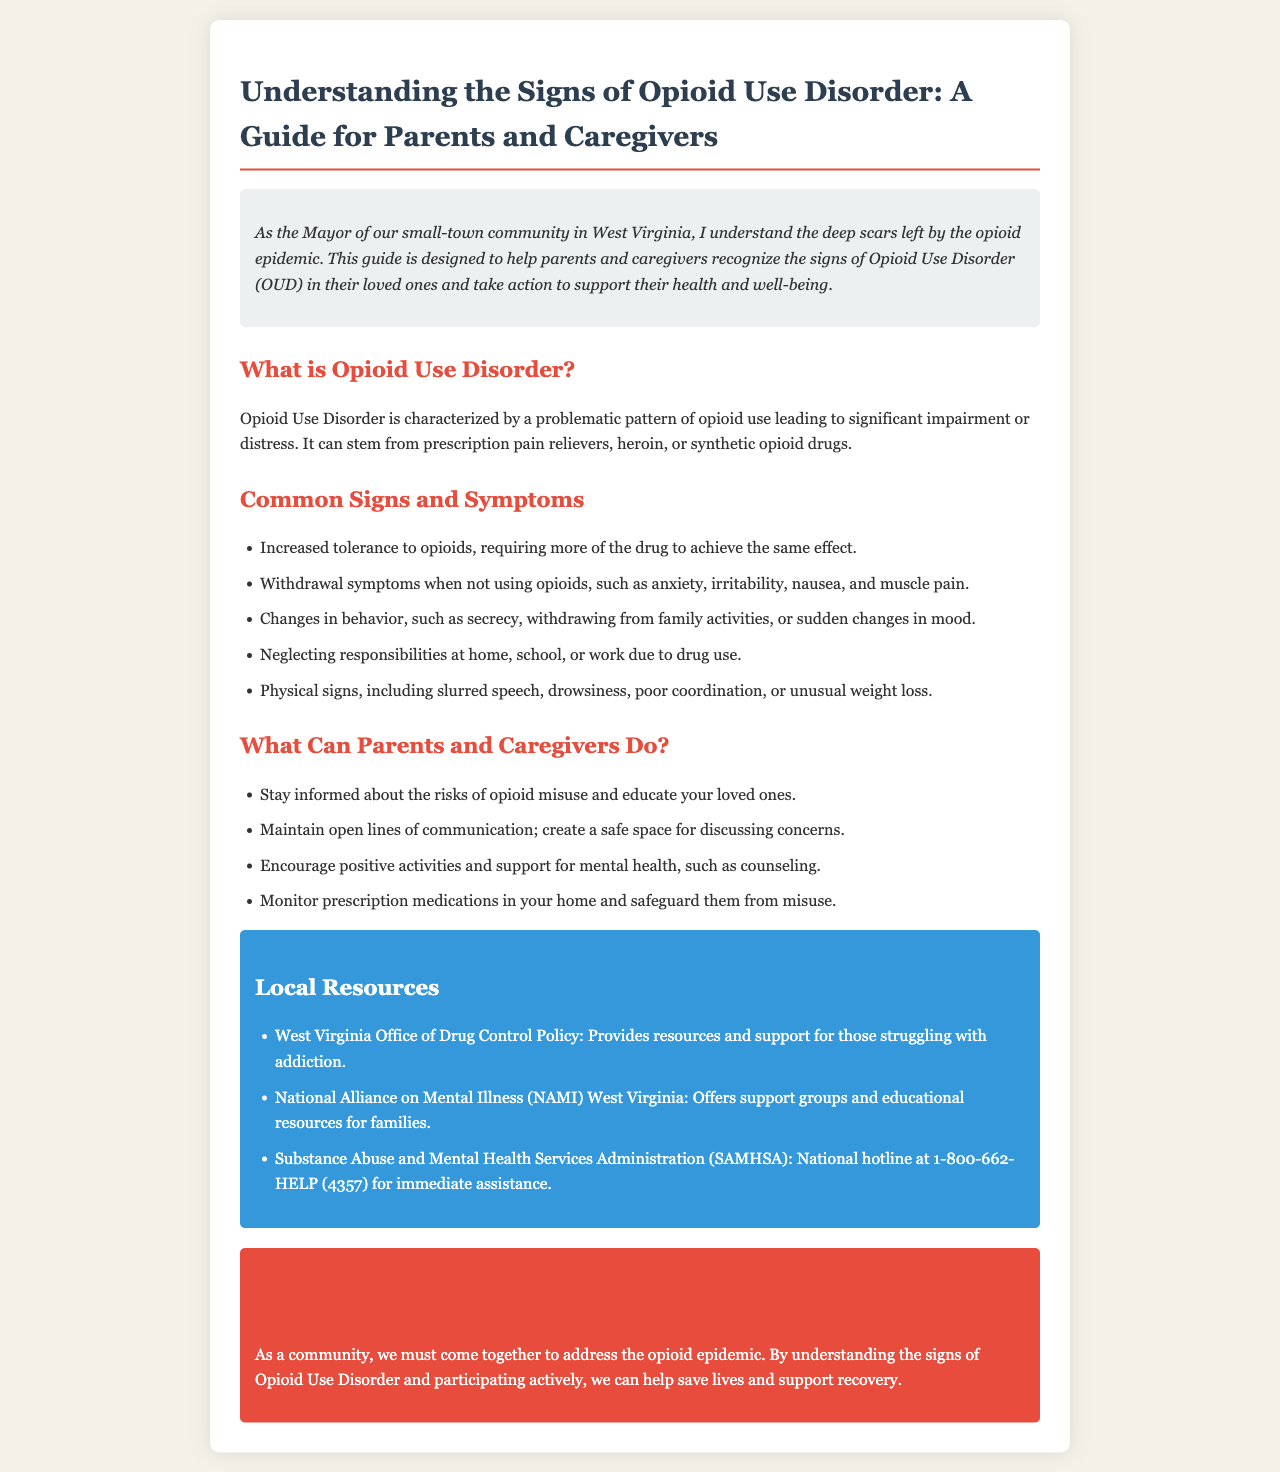What is Opioid Use Disorder? Opioid Use Disorder is defined in the document as a problematic pattern of opioid use leading to significant impairment or distress.
Answer: problematic pattern of opioid use What are physical signs of opioid use? The document lists physical signs of opioid use such as drowsiness and poor coordination.
Answer: drowsiness, poor coordination What should parents do to safeguard medications? The brochure suggests that parents should monitor and safeguard prescription medications from misuse.
Answer: Monitor and safeguard What resources are mentioned for support? The brochure includes several local resources such as the West Virginia Office of Drug Control Policy.
Answer: West Virginia Office of Drug Control Policy What is one way to foster communication with loved ones? The document emphasizes the importance of maintaining open lines of communication with loved ones.
Answer: open lines of communication How does the guide describe the severity of Opioid Use Disorder? It mentions that OUD leads to significant impairment or distress, indicating its severity.
Answer: significant impairment or distress What is the purpose of the brochure? The introduction states that the purpose is to help parents recognize the signs of Opioid Use Disorder.
Answer: recognize the signs of Opioid Use Disorder What color is used for the conclusion section? The brochure indicates that the conclusion section has a red background color.
Answer: red What is a suggested action for caregivers? One suggested action for caregivers is to encourage positive activities and support for mental health.
Answer: encourage positive activities 